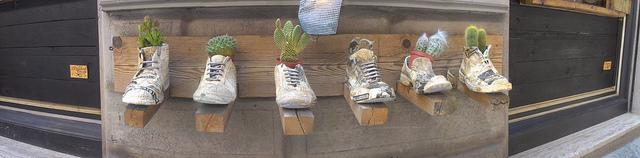Which shoes require watering more than daily? Please explain your reasoning. none. The shoes all have cacti planted in them and they don't require a lot of water. 